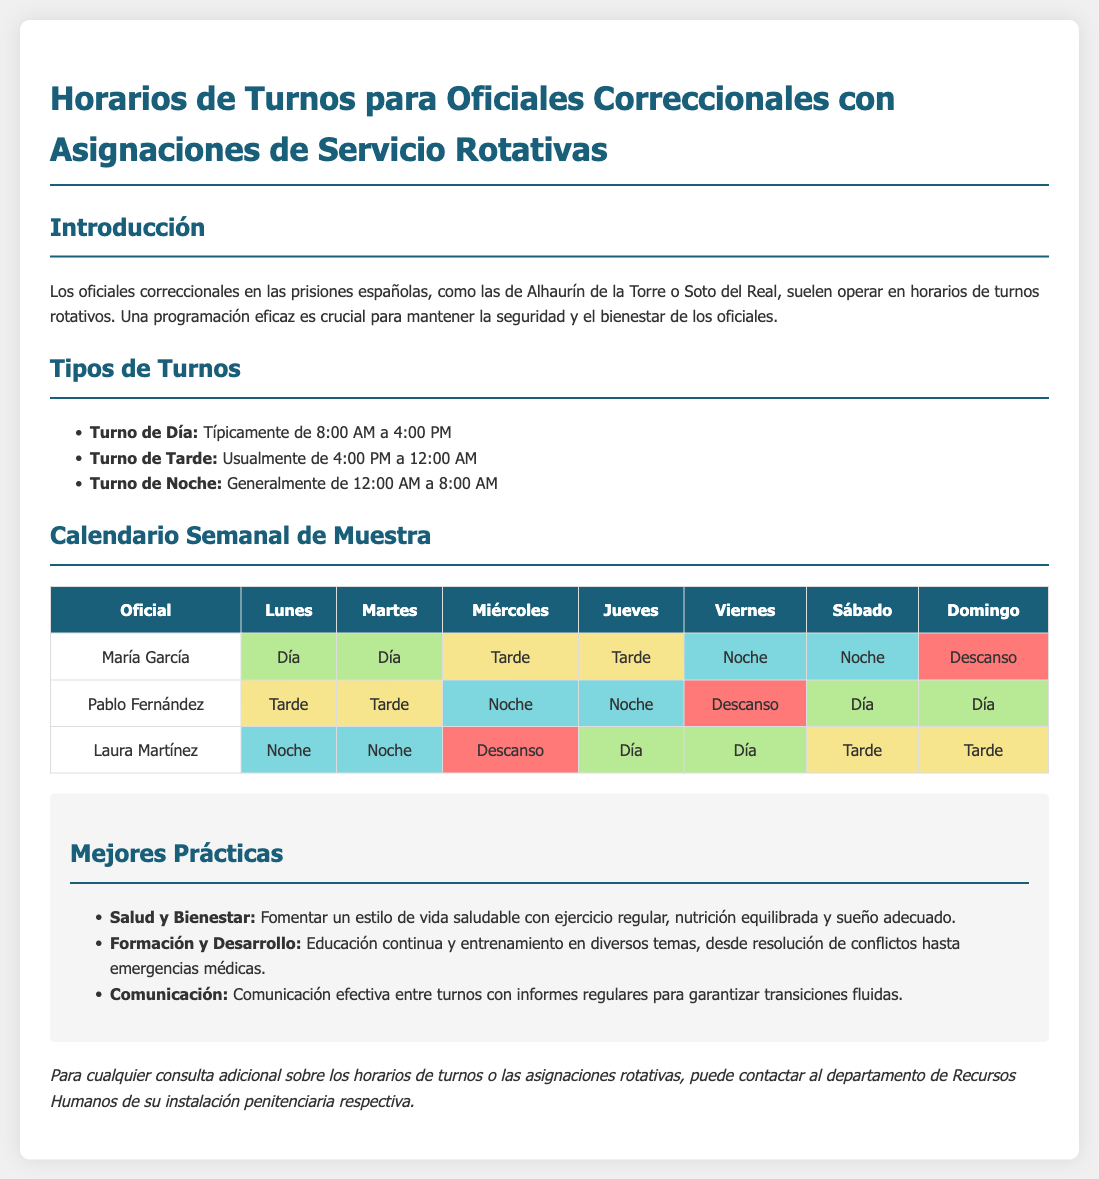¿Quién tiene turno de día el lunes? Según la tabla, María García trabaja el turno de día el lunes.
Answer: María García ¿Cuáles son los horarios del turno de noche? El documento señala que el turno de noche es generalmente de 12:00 AM a 8:00 AM.
Answer: 12:00 AM a 8:00 AM ¿Cuántos días de descanso tiene Pablo Fernández en la semana? La tabla muestra que Pablo Fernández tiene un día de descanso en la semana, que es el viernes.
Answer: 1 ¿Qué tipo de turno tiene Laura Martínez el miércoles? De acuerdo con la tabla, Laura Martínez tiene un día de descanso el miércoles.
Answer: Descanso ¿Cuál es el color que representa el turno de tarde? En el documento, el color que representa el turno de tarde es el amarillo claro.
Answer: Amarillo claro ¿Cuántos oficiales hay en el calendario? La tabla incluye tres oficiales: María García, Pablo Fernández y Laura Martínez.
Answer: 3 ¿Qué se sugiere para el bienestar de los oficiales? El documento menciona que se debe fomentar un estilo de vida saludable.
Answer: Estilo de vida saludable ¿Cuáles son las horas del turno de día? El documento indica que el turno de día es típicamente de 8:00 AM a 4:00 PM.
Answer: 8:00 AM a 4:00 PM 